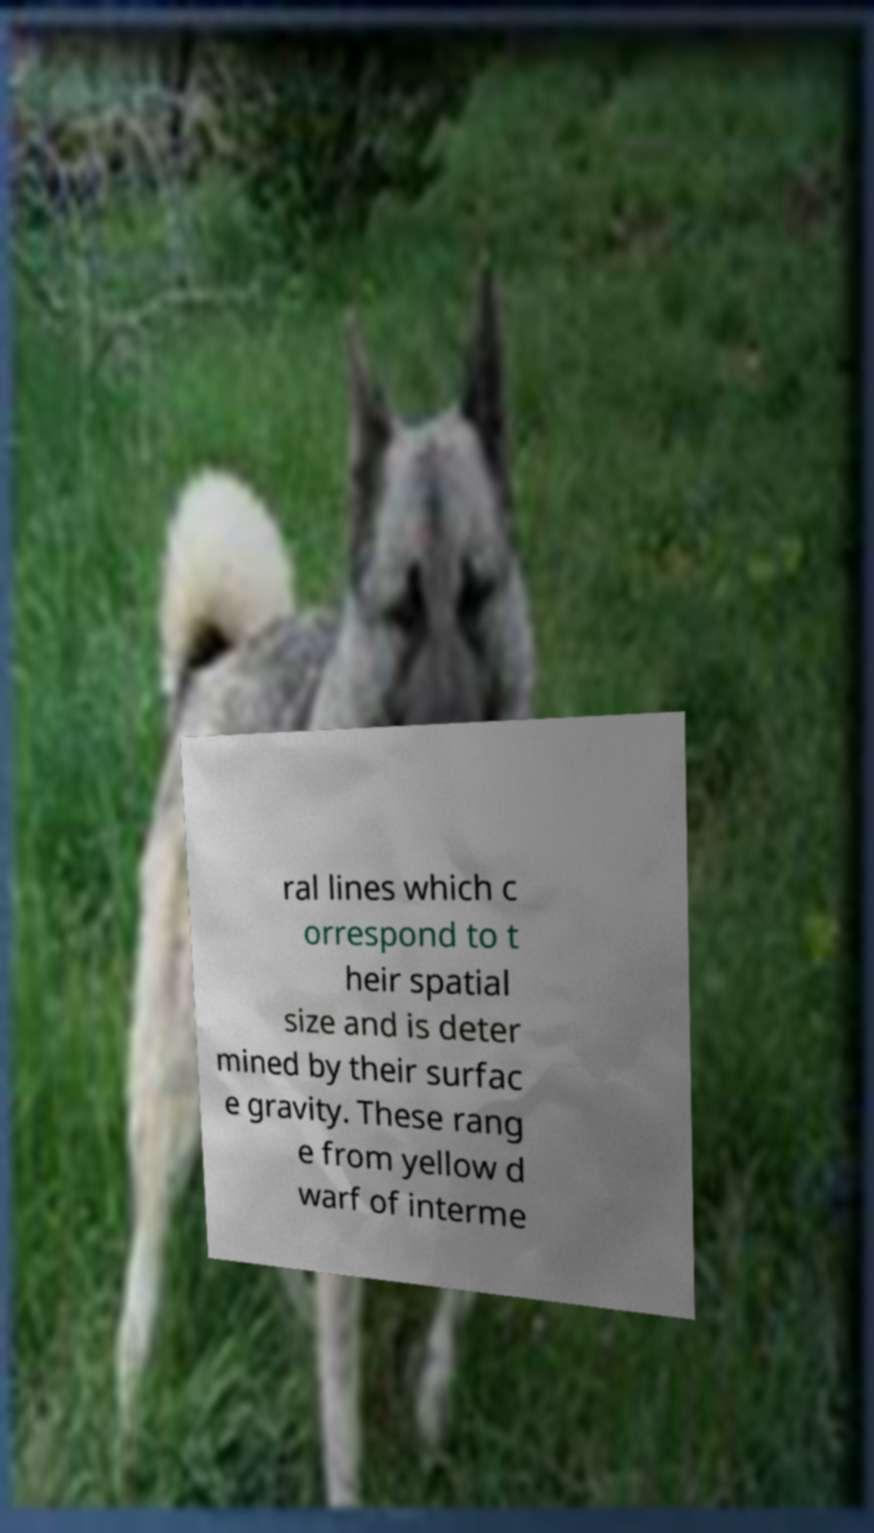Could you assist in decoding the text presented in this image and type it out clearly? ral lines which c orrespond to t heir spatial size and is deter mined by their surfac e gravity. These rang e from yellow d warf of interme 